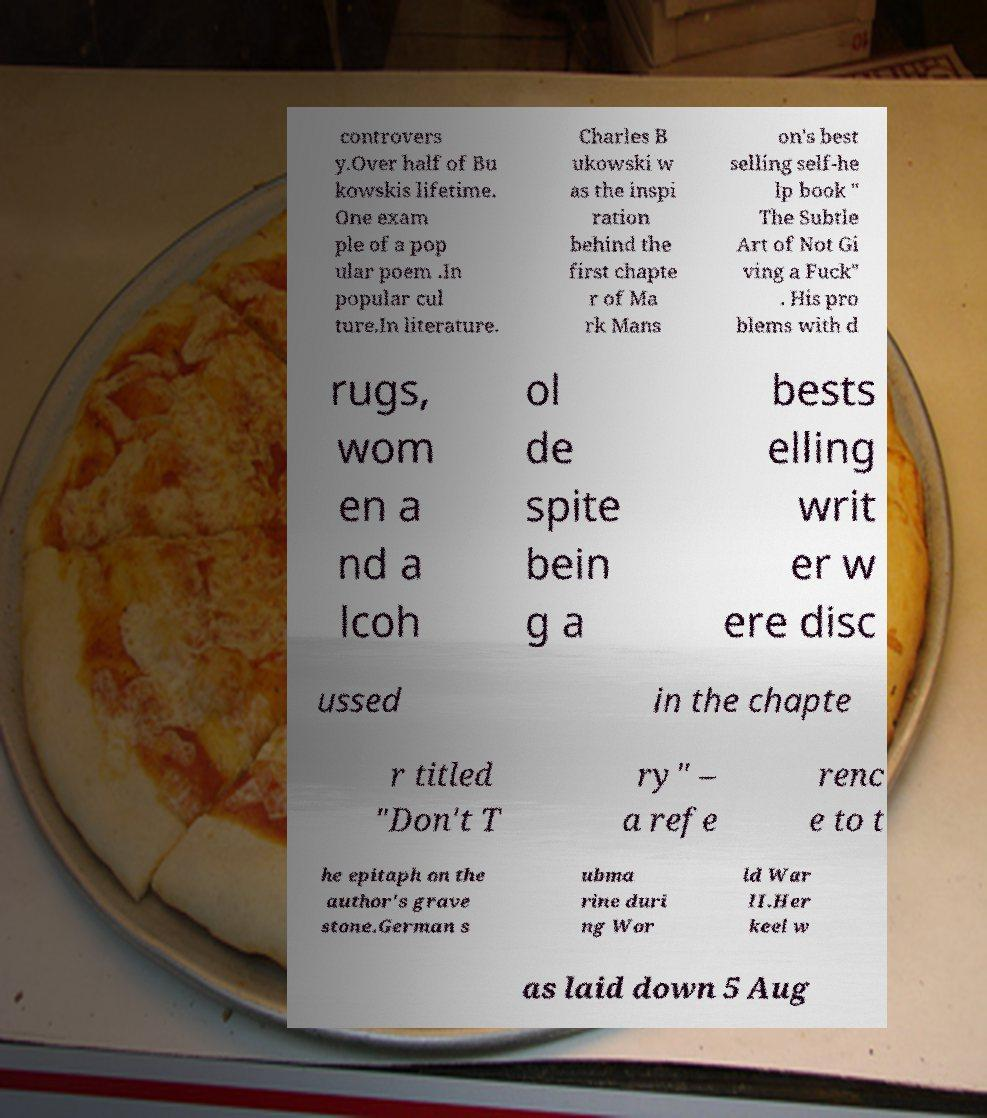For documentation purposes, I need the text within this image transcribed. Could you provide that? controvers y.Over half of Bu kowskis lifetime. One exam ple of a pop ular poem .In popular cul ture.In literature. Charles B ukowski w as the inspi ration behind the first chapte r of Ma rk Mans on's best selling self-he lp book " The Subtle Art of Not Gi ving a Fuck" . His pro blems with d rugs, wom en a nd a lcoh ol de spite bein g a bests elling writ er w ere disc ussed in the chapte r titled "Don't T ry" – a refe renc e to t he epitaph on the author's grave stone.German s ubma rine duri ng Wor ld War II.Her keel w as laid down 5 Aug 